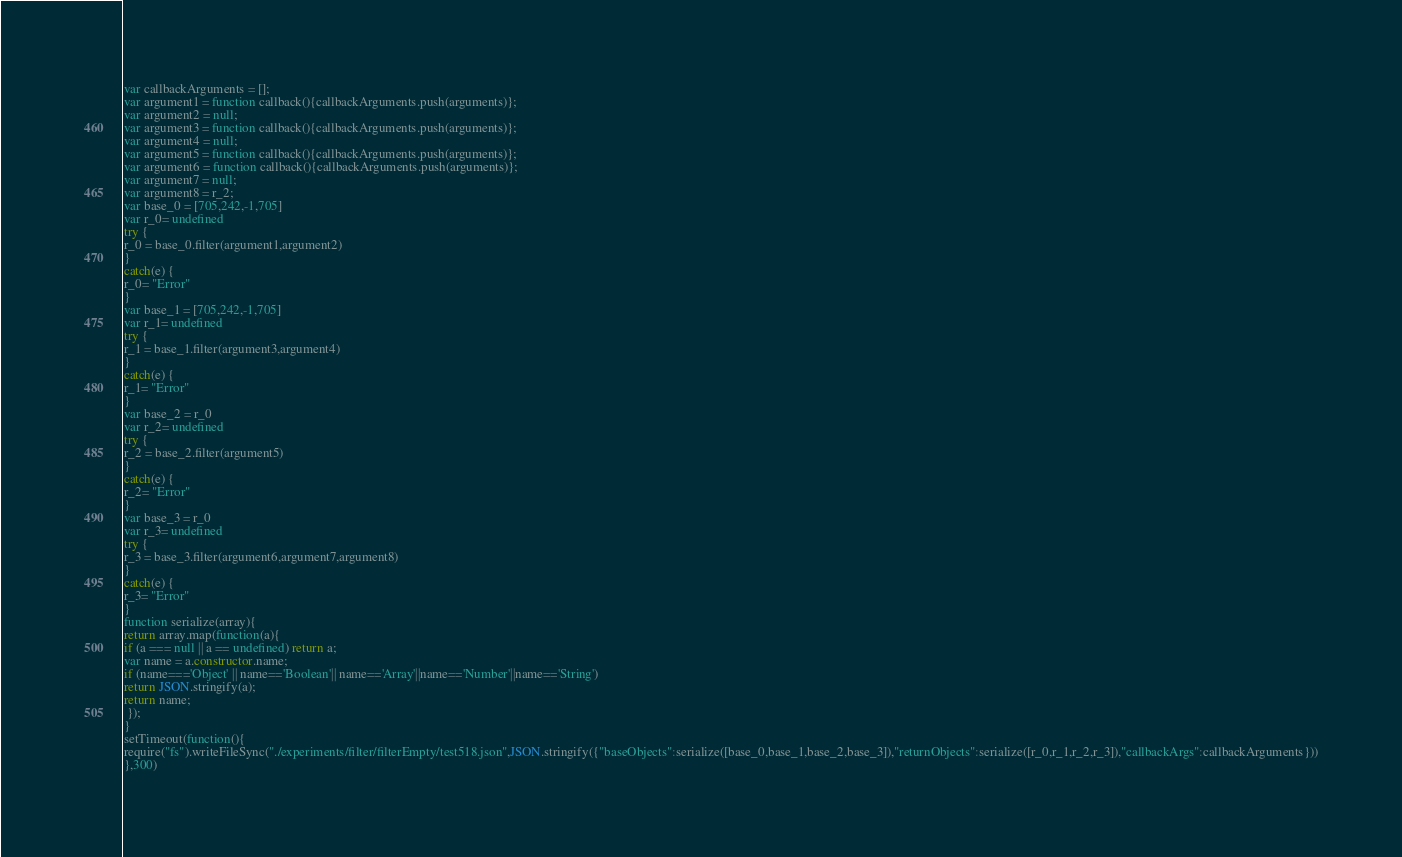Convert code to text. <code><loc_0><loc_0><loc_500><loc_500><_JavaScript_>





var callbackArguments = [];
var argument1 = function callback(){callbackArguments.push(arguments)};
var argument2 = null;
var argument3 = function callback(){callbackArguments.push(arguments)};
var argument4 = null;
var argument5 = function callback(){callbackArguments.push(arguments)};
var argument6 = function callback(){callbackArguments.push(arguments)};
var argument7 = null;
var argument8 = r_2;
var base_0 = [705,242,-1,705]
var r_0= undefined
try {
r_0 = base_0.filter(argument1,argument2)
}
catch(e) {
r_0= "Error"
}
var base_1 = [705,242,-1,705]
var r_1= undefined
try {
r_1 = base_1.filter(argument3,argument4)
}
catch(e) {
r_1= "Error"
}
var base_2 = r_0
var r_2= undefined
try {
r_2 = base_2.filter(argument5)
}
catch(e) {
r_2= "Error"
}
var base_3 = r_0
var r_3= undefined
try {
r_3 = base_3.filter(argument6,argument7,argument8)
}
catch(e) {
r_3= "Error"
}
function serialize(array){
return array.map(function(a){
if (a === null || a == undefined) return a;
var name = a.constructor.name;
if (name==='Object' || name=='Boolean'|| name=='Array'||name=='Number'||name=='String')
return JSON.stringify(a);
return name;
 });
}
setTimeout(function(){
require("fs").writeFileSync("./experiments/filter/filterEmpty/test518.json",JSON.stringify({"baseObjects":serialize([base_0,base_1,base_2,base_3]),"returnObjects":serialize([r_0,r_1,r_2,r_3]),"callbackArgs":callbackArguments}))
},300)</code> 